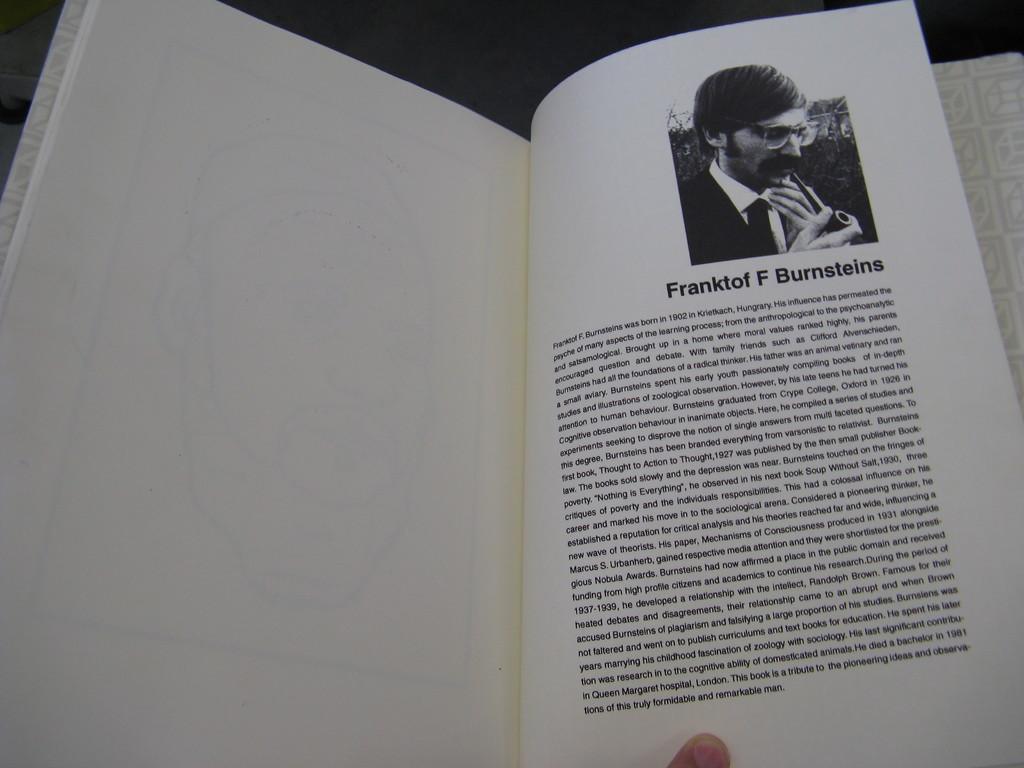Who is the author?
Give a very brief answer. Franktof f burnsteins. 